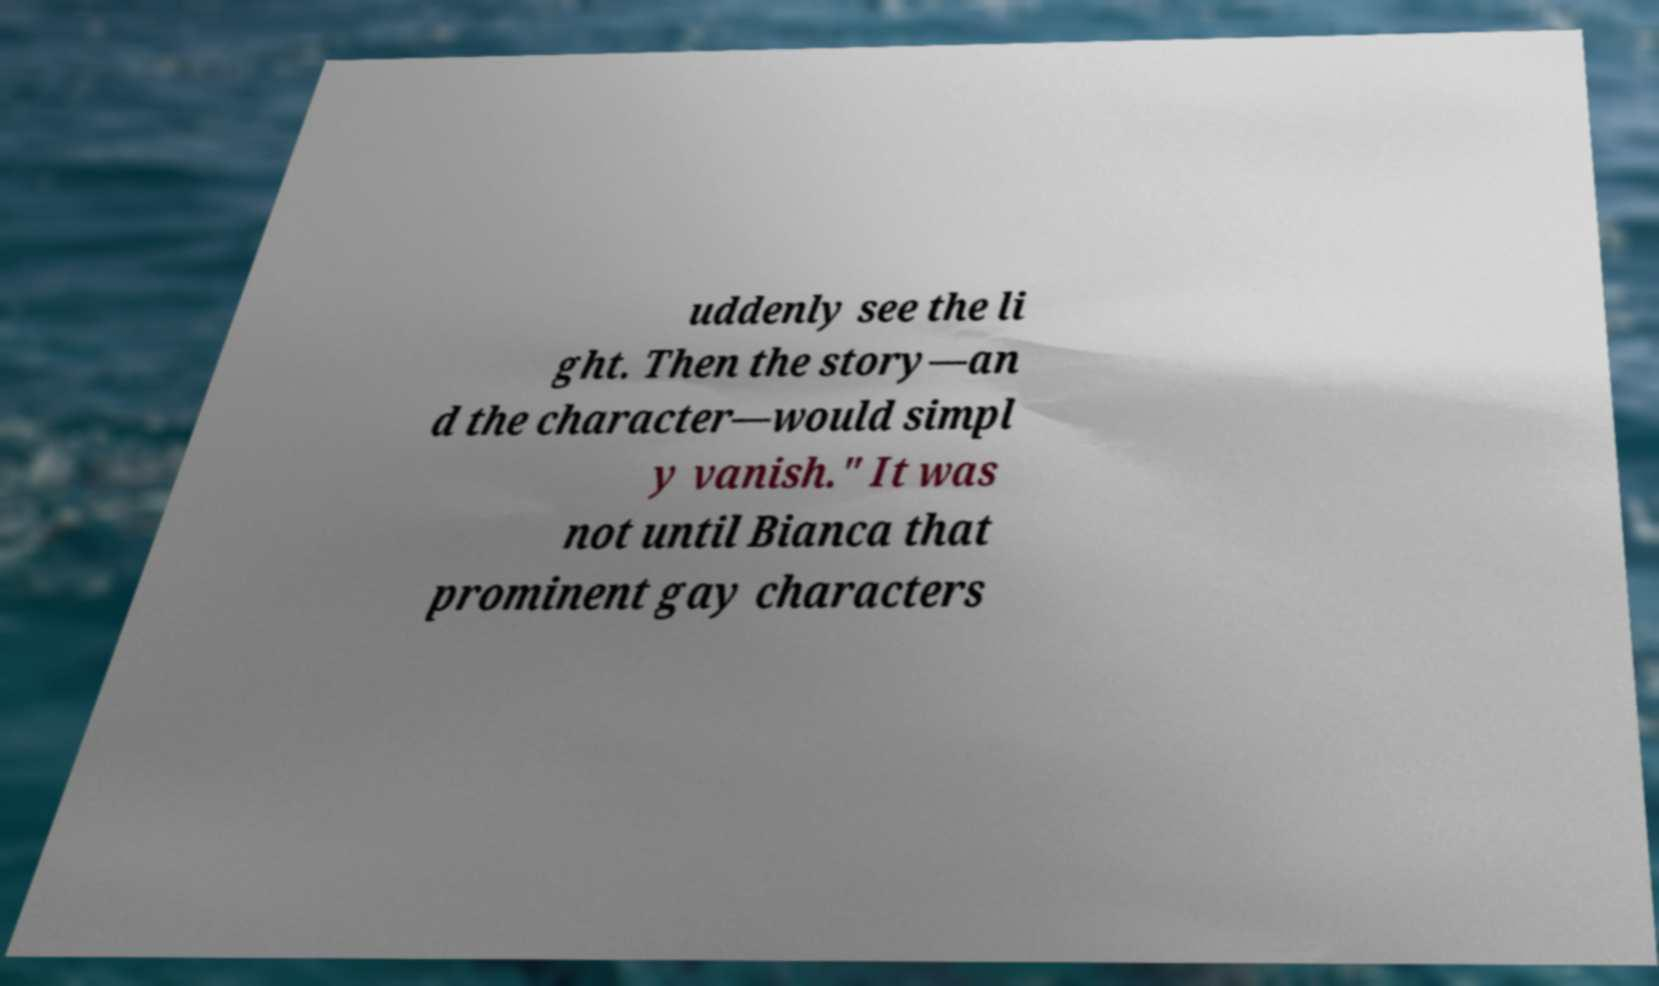Can you accurately transcribe the text from the provided image for me? uddenly see the li ght. Then the story—an d the character—would simpl y vanish." It was not until Bianca that prominent gay characters 